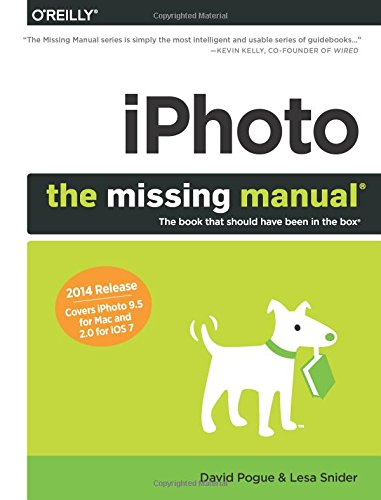Who are the intended readers of this manual? The intended readers are primarily Apple device users who are looking to enhance their photo management and editing skills using iPhoto. It's particularly useful for both amateur and experienced users getting accustomed to new updates or starting from scratch. 